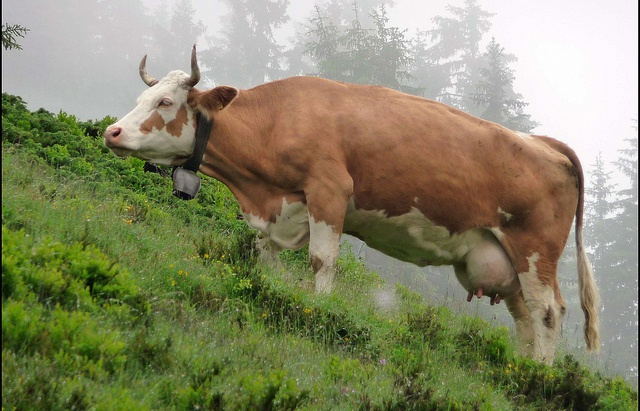Describe the objects in this image and their specific colors. I can see a cow in black, gray, maroon, and tan tones in this image. 